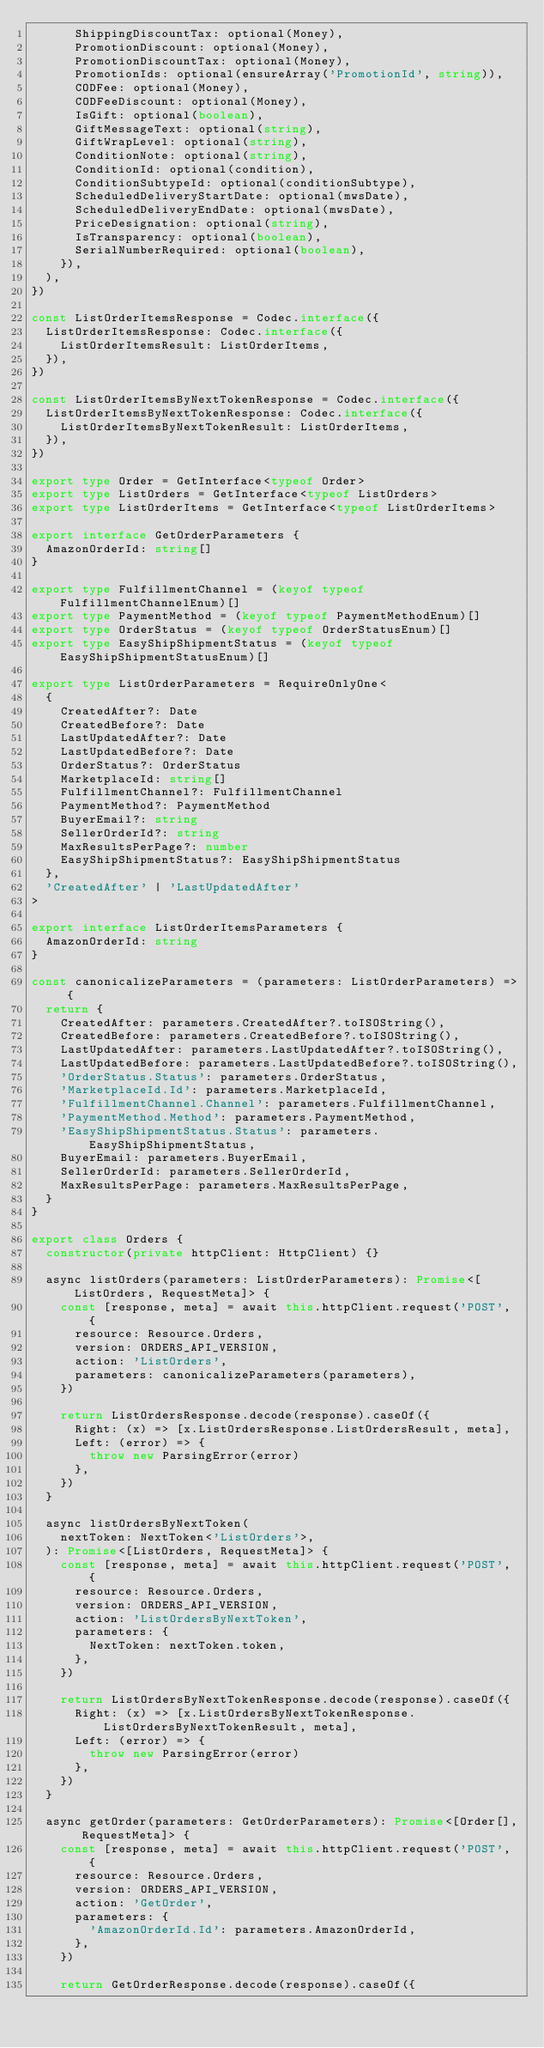Convert code to text. <code><loc_0><loc_0><loc_500><loc_500><_TypeScript_>      ShippingDiscountTax: optional(Money),
      PromotionDiscount: optional(Money),
      PromotionDiscountTax: optional(Money),
      PromotionIds: optional(ensureArray('PromotionId', string)),
      CODFee: optional(Money),
      CODFeeDiscount: optional(Money),
      IsGift: optional(boolean),
      GiftMessageText: optional(string),
      GiftWrapLevel: optional(string),
      ConditionNote: optional(string),
      ConditionId: optional(condition),
      ConditionSubtypeId: optional(conditionSubtype),
      ScheduledDeliveryStartDate: optional(mwsDate),
      ScheduledDeliveryEndDate: optional(mwsDate),
      PriceDesignation: optional(string),
      IsTransparency: optional(boolean),
      SerialNumberRequired: optional(boolean),
    }),
  ),
})

const ListOrderItemsResponse = Codec.interface({
  ListOrderItemsResponse: Codec.interface({
    ListOrderItemsResult: ListOrderItems,
  }),
})

const ListOrderItemsByNextTokenResponse = Codec.interface({
  ListOrderItemsByNextTokenResponse: Codec.interface({
    ListOrderItemsByNextTokenResult: ListOrderItems,
  }),
})

export type Order = GetInterface<typeof Order>
export type ListOrders = GetInterface<typeof ListOrders>
export type ListOrderItems = GetInterface<typeof ListOrderItems>

export interface GetOrderParameters {
  AmazonOrderId: string[]
}

export type FulfillmentChannel = (keyof typeof FulfillmentChannelEnum)[]
export type PaymentMethod = (keyof typeof PaymentMethodEnum)[]
export type OrderStatus = (keyof typeof OrderStatusEnum)[]
export type EasyShipShipmentStatus = (keyof typeof EasyShipShipmentStatusEnum)[]

export type ListOrderParameters = RequireOnlyOne<
  {
    CreatedAfter?: Date
    CreatedBefore?: Date
    LastUpdatedAfter?: Date
    LastUpdatedBefore?: Date
    OrderStatus?: OrderStatus
    MarketplaceId: string[]
    FulfillmentChannel?: FulfillmentChannel
    PaymentMethod?: PaymentMethod
    BuyerEmail?: string
    SellerOrderId?: string
    MaxResultsPerPage?: number
    EasyShipShipmentStatus?: EasyShipShipmentStatus
  },
  'CreatedAfter' | 'LastUpdatedAfter'
>

export interface ListOrderItemsParameters {
  AmazonOrderId: string
}

const canonicalizeParameters = (parameters: ListOrderParameters) => {
  return {
    CreatedAfter: parameters.CreatedAfter?.toISOString(),
    CreatedBefore: parameters.CreatedBefore?.toISOString(),
    LastUpdatedAfter: parameters.LastUpdatedAfter?.toISOString(),
    LastUpdatedBefore: parameters.LastUpdatedBefore?.toISOString(),
    'OrderStatus.Status': parameters.OrderStatus,
    'MarketplaceId.Id': parameters.MarketplaceId,
    'FulfillmentChannel.Channel': parameters.FulfillmentChannel,
    'PaymentMethod.Method': parameters.PaymentMethod,
    'EasyShipShipmentStatus.Status': parameters.EasyShipShipmentStatus,
    BuyerEmail: parameters.BuyerEmail,
    SellerOrderId: parameters.SellerOrderId,
    MaxResultsPerPage: parameters.MaxResultsPerPage,
  }
}

export class Orders {
  constructor(private httpClient: HttpClient) {}

  async listOrders(parameters: ListOrderParameters): Promise<[ListOrders, RequestMeta]> {
    const [response, meta] = await this.httpClient.request('POST', {
      resource: Resource.Orders,
      version: ORDERS_API_VERSION,
      action: 'ListOrders',
      parameters: canonicalizeParameters(parameters),
    })

    return ListOrdersResponse.decode(response).caseOf({
      Right: (x) => [x.ListOrdersResponse.ListOrdersResult, meta],
      Left: (error) => {
        throw new ParsingError(error)
      },
    })
  }

  async listOrdersByNextToken(
    nextToken: NextToken<'ListOrders'>,
  ): Promise<[ListOrders, RequestMeta]> {
    const [response, meta] = await this.httpClient.request('POST', {
      resource: Resource.Orders,
      version: ORDERS_API_VERSION,
      action: 'ListOrdersByNextToken',
      parameters: {
        NextToken: nextToken.token,
      },
    })

    return ListOrdersByNextTokenResponse.decode(response).caseOf({
      Right: (x) => [x.ListOrdersByNextTokenResponse.ListOrdersByNextTokenResult, meta],
      Left: (error) => {
        throw new ParsingError(error)
      },
    })
  }

  async getOrder(parameters: GetOrderParameters): Promise<[Order[], RequestMeta]> {
    const [response, meta] = await this.httpClient.request('POST', {
      resource: Resource.Orders,
      version: ORDERS_API_VERSION,
      action: 'GetOrder',
      parameters: {
        'AmazonOrderId.Id': parameters.AmazonOrderId,
      },
    })

    return GetOrderResponse.decode(response).caseOf({</code> 